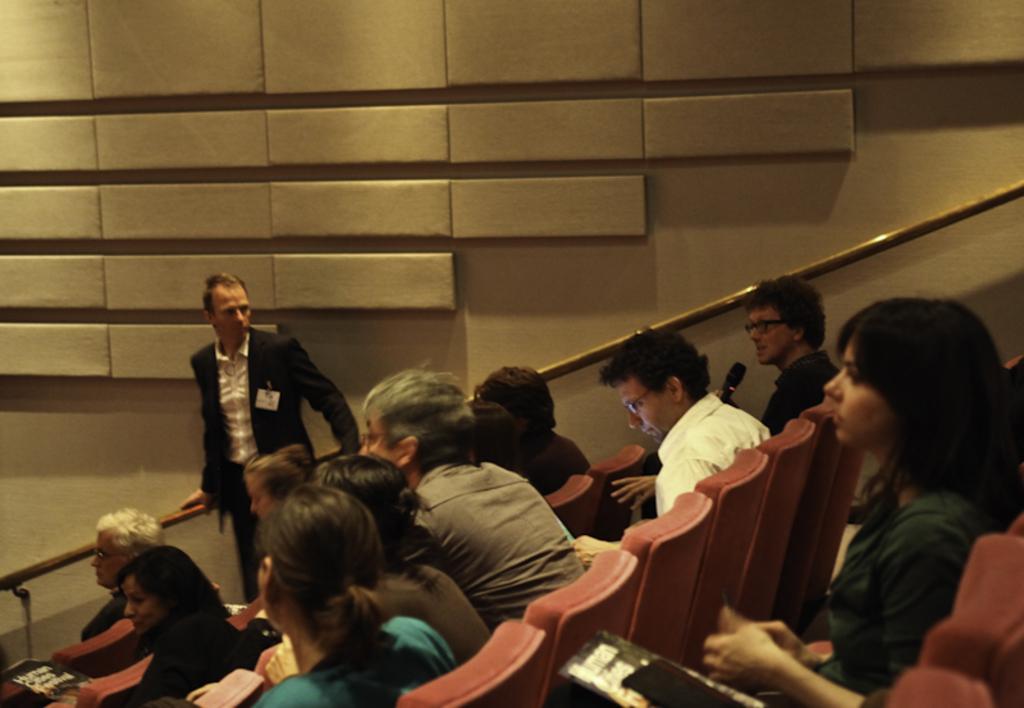How would you summarize this image in a sentence or two? In this image, I can see a group of people sitting on the chairs and a person standing. In the background, there is a staircase holder, which is attached to the wall. 